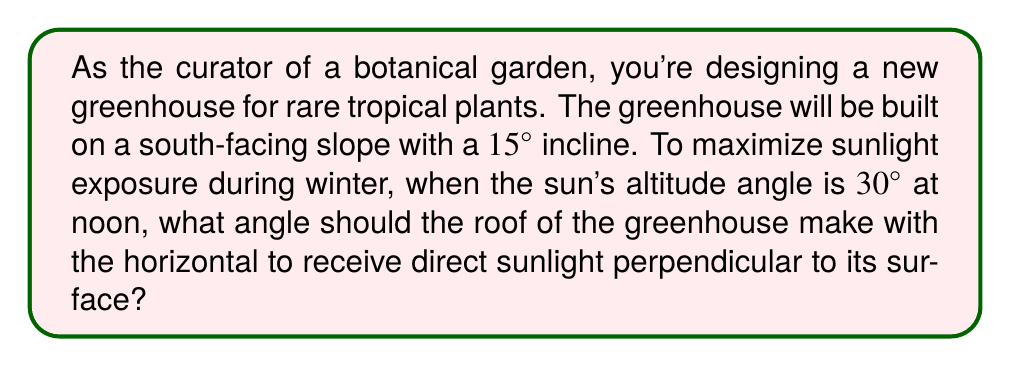Solve this math problem. Let's approach this step-by-step:

1) First, let's visualize the problem:
   [asy]
   import geometry;
   
   size(200);
   
   pair A=(0,0), B=(100,0), C=(100,26.79), D=(0,26.79);
   pair E=(150,86.6);
   
   draw(A--B--C--D--A);
   draw(B--E);
   draw(C--E,dashed);
   
   label("Ground",(-10,-10));
   label("Sun rays",E,E);
   label("Greenhouse roof",C,NE);
   label("15°",B,SW);
   label("30°",E,SE);
   label("x°",C,NW);
   
   markangle(B,E,C,radius=20);
   markangle(A,B,C,radius=15);
   markangle(B,C,E,radius=25,Arrow);
   [/asy]

2) We want the sun's rays to be perpendicular to the greenhouse roof. This means that the angle between the sun's rays and the roof should be 90°.

3) Let $x$ be the angle we're looking for (the angle between the roof and the horizontal).

4) The sun's altitude angle is 30°, and the ground has a 15° incline. So the angle between the sun's rays and the inclined ground is:
   $$ 30° - 15° = 15° $$

5) Now, we can set up an equation based on the fact that the angles in a triangle sum to 180°:
   $$ x + 15° + 90° = 180° $$

6) Solving for $x$:
   $$ x = 180° - 15° - 90° = 75° $$

7) Therefore, the greenhouse roof should make a 75° angle with the horizontal.
Answer: 75° 